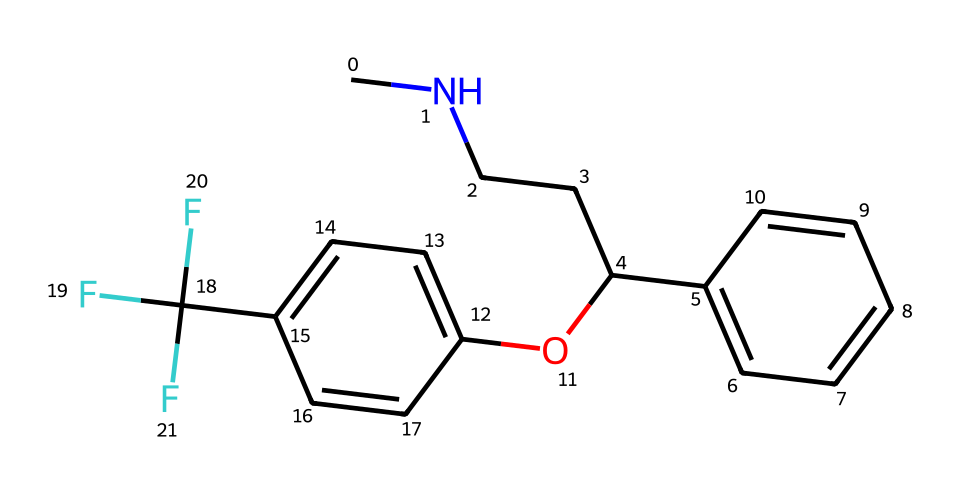What is the molecular formula of fluoxetine? To find the molecular formula, identify the elements present in the chemical structure using the SMILES notation. The structure indicates that it contains carbon (C), hydrogen (H), nitrogen (N), oxygen (O), and fluorine (F). Count the number of each type of atom: there are 17 carbons, 18 hydrogens, 1 nitrogen, 1 oxygen, and 3 fluorines, leading to the molecular formula C17H18F3N.
Answer: C17H18F3N How many rings are present in the structure of fluoxetine? Inspect the chemical structure for any cyclic compounds. There are two aromatic rings indicated in the structure, which are characterized by alternating double bonds within the rings.
Answer: 2 What type of functional group is present in fluoxetine? Review the SMILES to identify its functional groups. The ether functional group is evident from the "O" between two carbon-containing molecules, suggesting the presence of an ether (-O-) bond.
Answer: ether What is the impact of the trifluoromethyl group (-C(F)(F)F) on fluoxetine's properties? The trifluoromethyl group contributes to the lipophilicity and metabolic stability of fluoxetine, enhancing its bioavailability and effects as an antidepressant. The presence of three fluorine atoms increases the molecule's electronegativity and modifies how it interacts with receptors.
Answer: increases lipophilicity How does the nitrogen atom contribute to the properties of fluoxetine? The nitrogen atom in fluoxetine, part of the amine group, plays a crucial role in its interaction with neurotransmitter systems, such as serotonin. This nitrogen enhances the molecule's ability to bind to serotonin receptors, making it an effective antidepressant.
Answer: enables receptor binding 